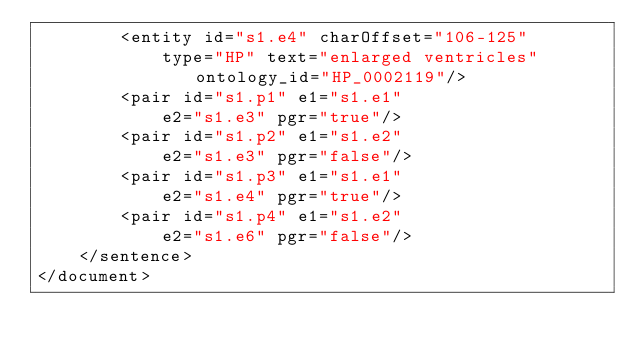Convert code to text. <code><loc_0><loc_0><loc_500><loc_500><_XML_>		<entity id="s1.e4" charOffset="106-125"
			type="HP" text="enlarged ventricles" ontology_id="HP_0002119"/>
		<pair id="s1.p1" e1="s1.e1"
		    e2="s1.e3" pgr="true"/>
		<pair id="s1.p2" e1="s1.e2"
		    e2="s1.e3" pgr="false"/>
		<pair id="s1.p3" e1="s1.e1"
		    e2="s1.e4" pgr="true"/>
		<pair id="s1.p4" e1="s1.e2"
		    e2="s1.e6" pgr="false"/>
	</sentence>
</document>
</code> 